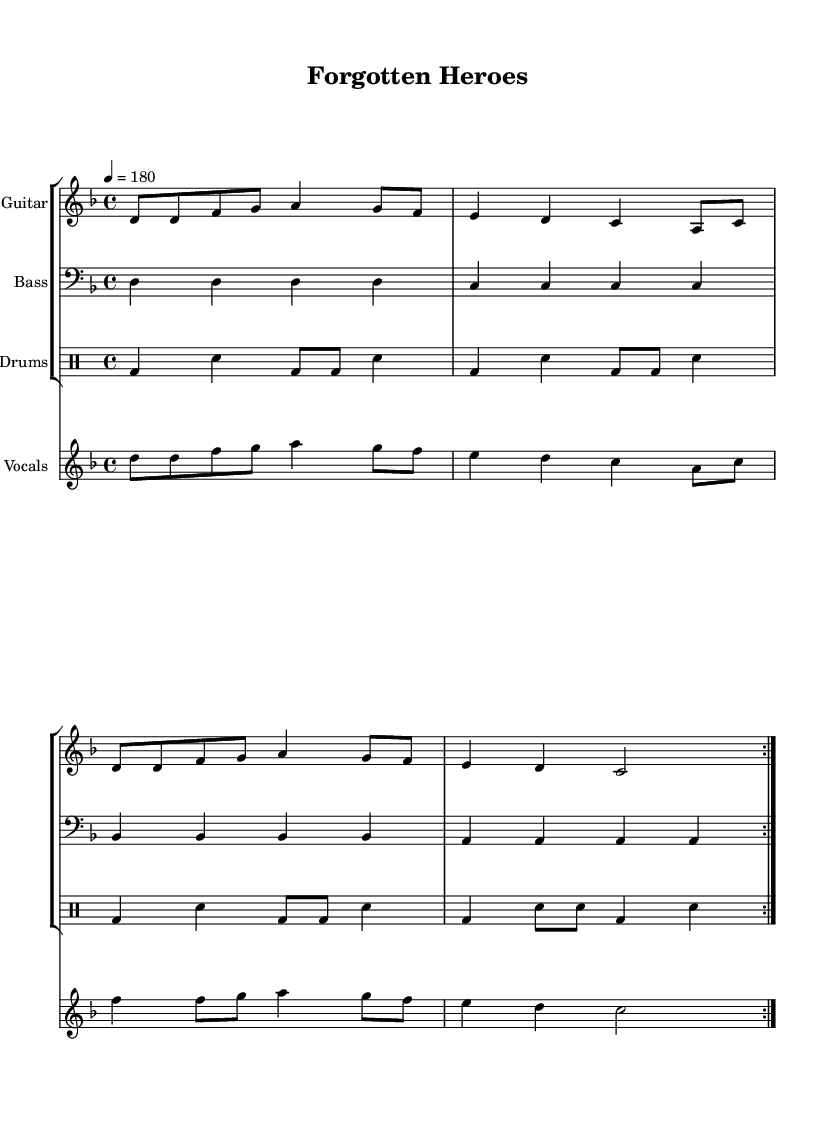What is the key signature of this music? The key signature is indicated by the sharp or flat symbols at the beginning of the staff. In this case, there are no sharps or flats, indicating D minor, which has one flat.
Answer: D minor What is the time signature of this music? The time signature is represented as a fraction at the beginning of the score. Here, it reads 4/4, indicating four beats in each measure.
Answer: 4/4 What is the tempo marking of this music? The tempo is indicated as a number with a symbol, which refers to the beats per minute (BPM). In this sheet music, it states "4 = 180," meaning there are 180 quarter-note beats in a minute.
Answer: 180 How many measures are in the section for the electric guitar? We count the number of times the guitar part is written, and based on the repeated sections and the notation, there are four complete measures.
Answer: 4 What instruments are included in this score? The instruments are mentioned at the beginning of each staff. In this score, there are three instruments: electric guitar, bass guitar, and drums.
Answer: Electric guitar, bass guitar, and drums What style of lyrics is used in this song? The lyrics appear underneath the vocal line and seem to express a critical view of war, indicating a thematic focus on political awareness often found in punk music.
Answer: Political critique How does the electric guitar section relate to the lyrical theme? The electric guitar part complements the lyrics by emphasizing the energy and urgency typical of punk music. The rhythm and fast tempo underline the critique of the glorification of war, reflecting the punk ethos.
Answer: It emphasizes urgency and critique 